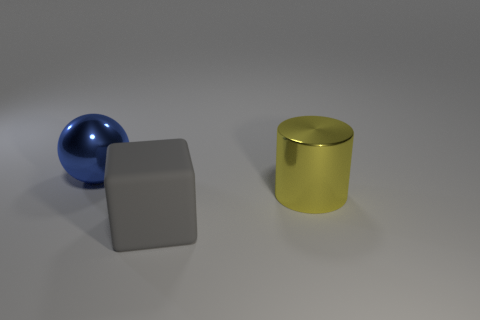What is the shape of the big gray object?
Give a very brief answer. Cube. What number of green things are balls or shiny objects?
Offer a very short reply. 0. How many other things are there of the same material as the big sphere?
Give a very brief answer. 1. Do the metallic object that is left of the big cylinder and the big gray object have the same shape?
Offer a terse response. No. Are any yellow metal objects visible?
Offer a terse response. Yes. Is there any other thing that has the same shape as the yellow metallic object?
Provide a succinct answer. No. Are there more metallic objects to the right of the blue ball than spheres?
Give a very brief answer. No. Are there any spheres in front of the big shiny ball?
Give a very brief answer. No. Do the block and the blue shiny object have the same size?
Your answer should be very brief. Yes. Are there any other things that are the same size as the yellow cylinder?
Give a very brief answer. Yes. 